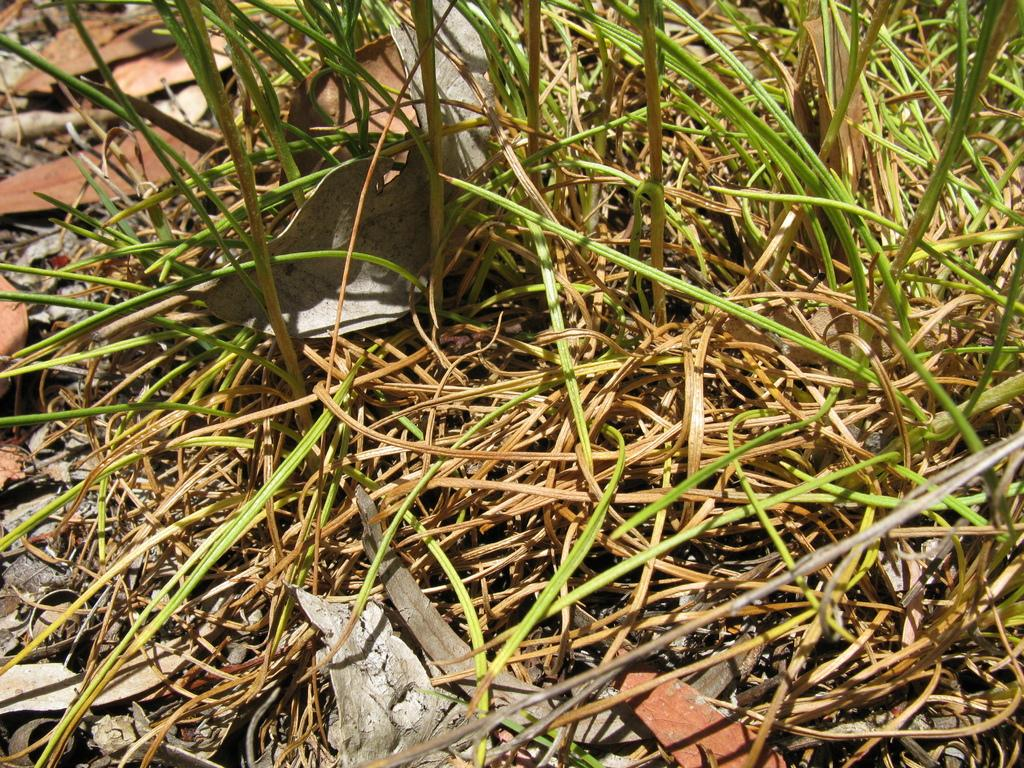What type of vegetation can be seen in the image? There is grass in the image. What else can be found on the ground in the image? Dry leaves are present in the image. How much honey can be seen dripping from the bushes in the image? There are no bushes or honey present in the image. 